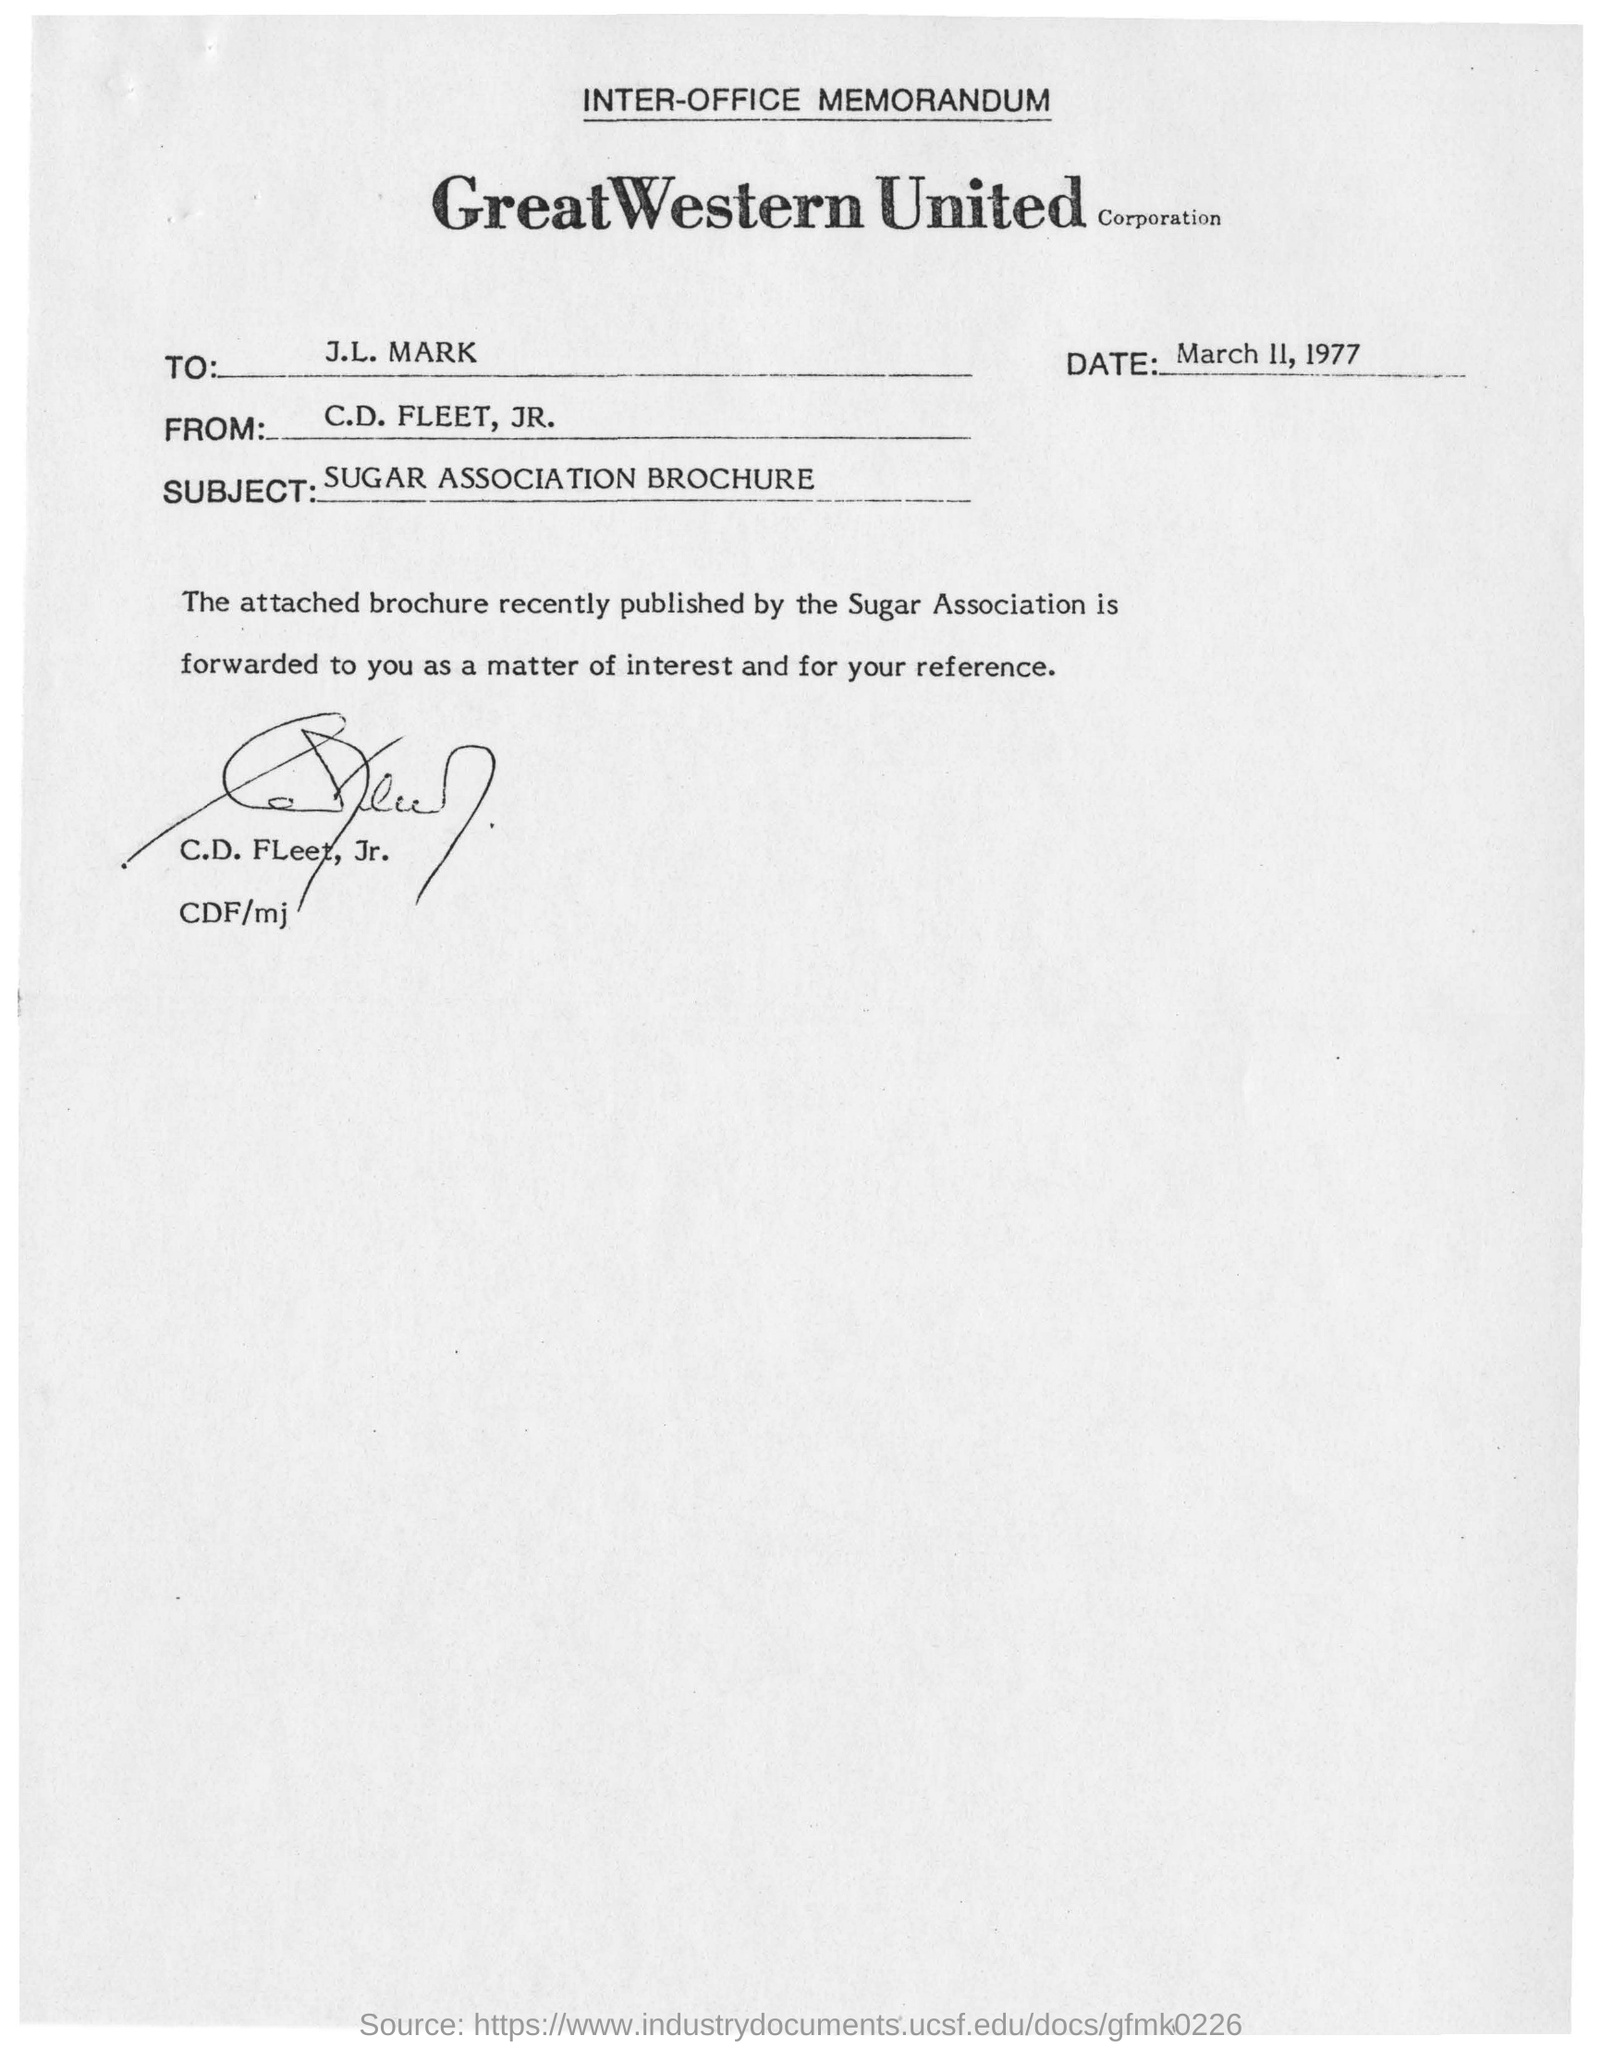Outline some significant characteristics in this image. The subject of the memorandum is the SUGAR ASSOCIATION BROCHURE. This memorandum is addressed to J.L. Mark. The memorandum was dated on March 11, 1977. 